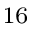<formula> <loc_0><loc_0><loc_500><loc_500>_ { 1 6 }</formula> 